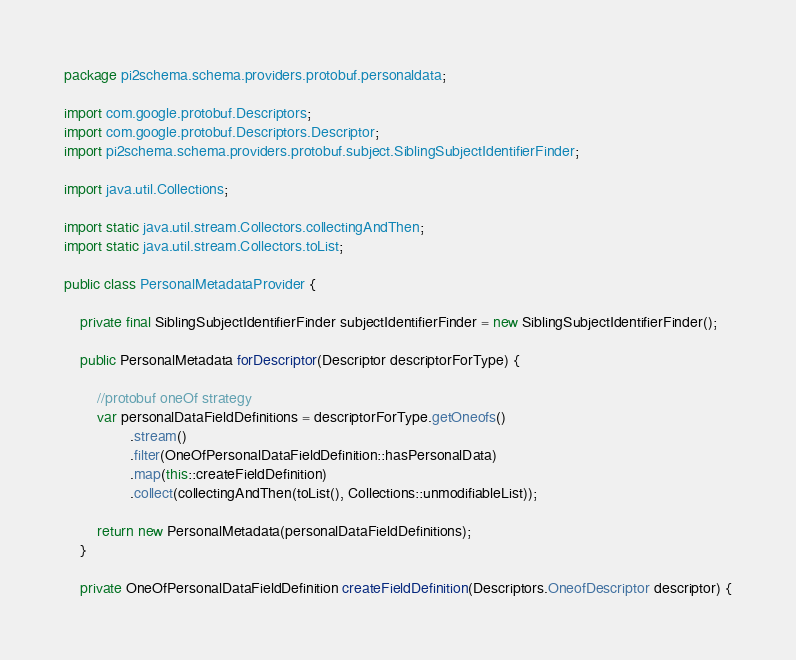Convert code to text. <code><loc_0><loc_0><loc_500><loc_500><_Java_>package pi2schema.schema.providers.protobuf.personaldata;

import com.google.protobuf.Descriptors;
import com.google.protobuf.Descriptors.Descriptor;
import pi2schema.schema.providers.protobuf.subject.SiblingSubjectIdentifierFinder;

import java.util.Collections;

import static java.util.stream.Collectors.collectingAndThen;
import static java.util.stream.Collectors.toList;

public class PersonalMetadataProvider {

    private final SiblingSubjectIdentifierFinder subjectIdentifierFinder = new SiblingSubjectIdentifierFinder();

    public PersonalMetadata forDescriptor(Descriptor descriptorForType) {

        //protobuf oneOf strategy
        var personalDataFieldDefinitions = descriptorForType.getOneofs()
                .stream()
                .filter(OneOfPersonalDataFieldDefinition::hasPersonalData)
                .map(this::createFieldDefinition)
                .collect(collectingAndThen(toList(), Collections::unmodifiableList));

        return new PersonalMetadata(personalDataFieldDefinitions);
    }

    private OneOfPersonalDataFieldDefinition createFieldDefinition(Descriptors.OneofDescriptor descriptor) {</code> 